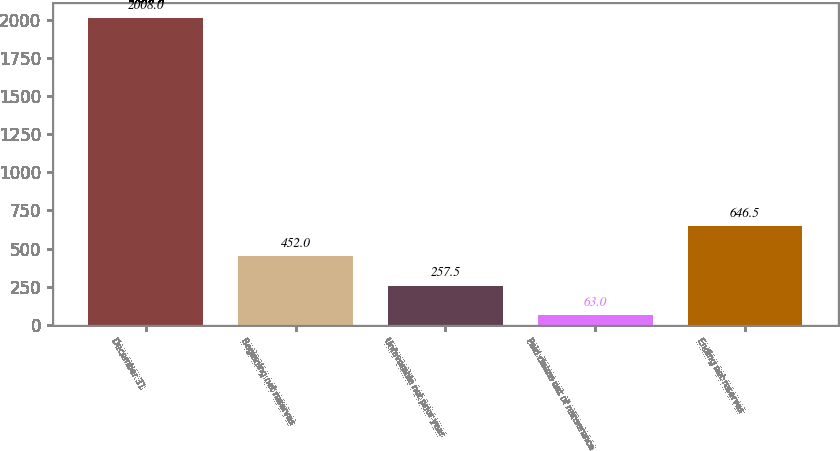Convert chart to OTSL. <chart><loc_0><loc_0><loc_500><loc_500><bar_chart><fcel>December 31<fcel>Beginning net reserves<fcel>Unfavorable net prior year<fcel>Paid claims net of reinsurance<fcel>Ending net reserves<nl><fcel>2008<fcel>452<fcel>257.5<fcel>63<fcel>646.5<nl></chart> 